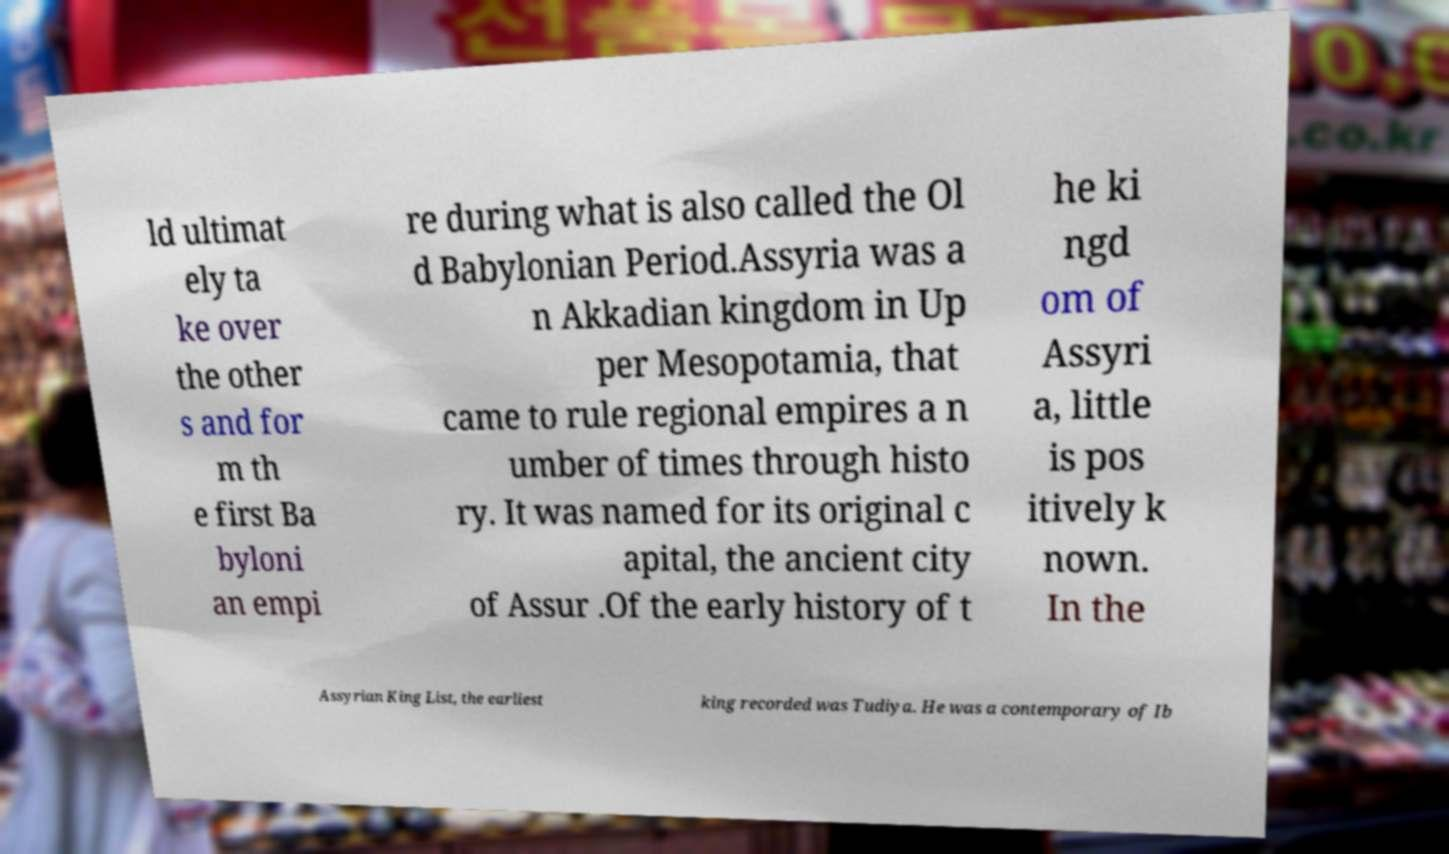Can you accurately transcribe the text from the provided image for me? ld ultimat ely ta ke over the other s and for m th e first Ba byloni an empi re during what is also called the Ol d Babylonian Period.Assyria was a n Akkadian kingdom in Up per Mesopotamia, that came to rule regional empires a n umber of times through histo ry. It was named for its original c apital, the ancient city of Assur .Of the early history of t he ki ngd om of Assyri a, little is pos itively k nown. In the Assyrian King List, the earliest king recorded was Tudiya. He was a contemporary of Ib 